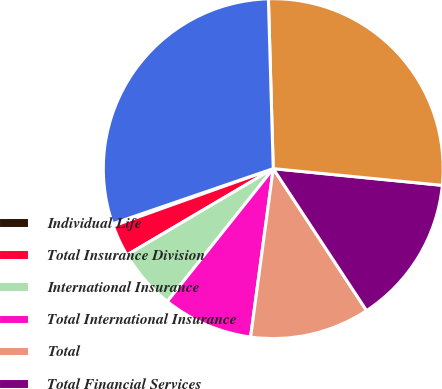<chart> <loc_0><loc_0><loc_500><loc_500><pie_chart><fcel>Individual Life<fcel>Total Insurance Division<fcel>International Insurance<fcel>Total International Insurance<fcel>Total<fcel>Total Financial Services<fcel>Closed Block Business<fcel>Total per Consolidated<nl><fcel>0.21%<fcel>3.01%<fcel>5.8%<fcel>8.59%<fcel>11.38%<fcel>14.18%<fcel>27.02%<fcel>29.81%<nl></chart> 